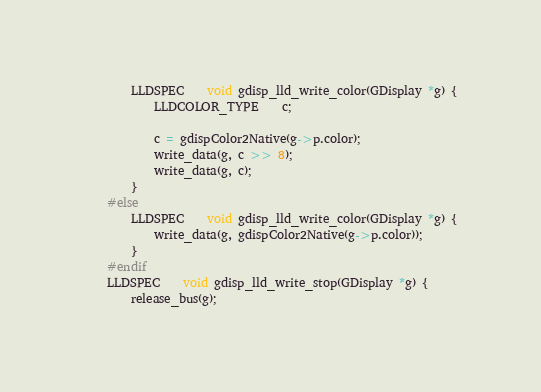Convert code to text. <code><loc_0><loc_0><loc_500><loc_500><_C_>		LLDSPEC	void gdisp_lld_write_color(GDisplay *g) {
			LLDCOLOR_TYPE	c;

			c = gdispColor2Native(g->p.color);
			write_data(g, c >> 8);
			write_data(g, c);
		}
	#else
		LLDSPEC	void gdisp_lld_write_color(GDisplay *g) {
			write_data(g, gdispColor2Native(g->p.color));
		}
	#endif
	LLDSPEC	void gdisp_lld_write_stop(GDisplay *g) {
		release_bus(g);</code> 